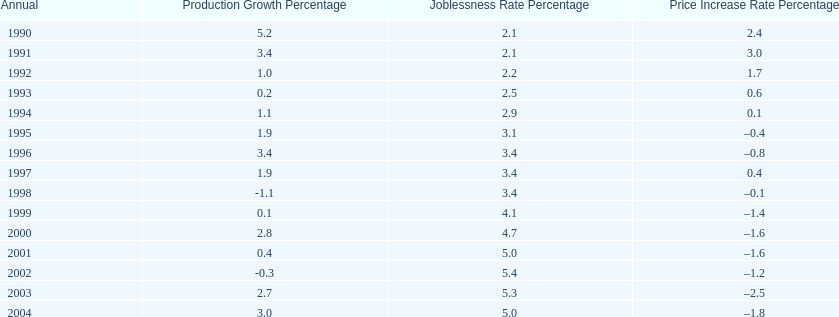What year saw the highest output growth rate in japan between the years 1990 and 2004? 1990. 